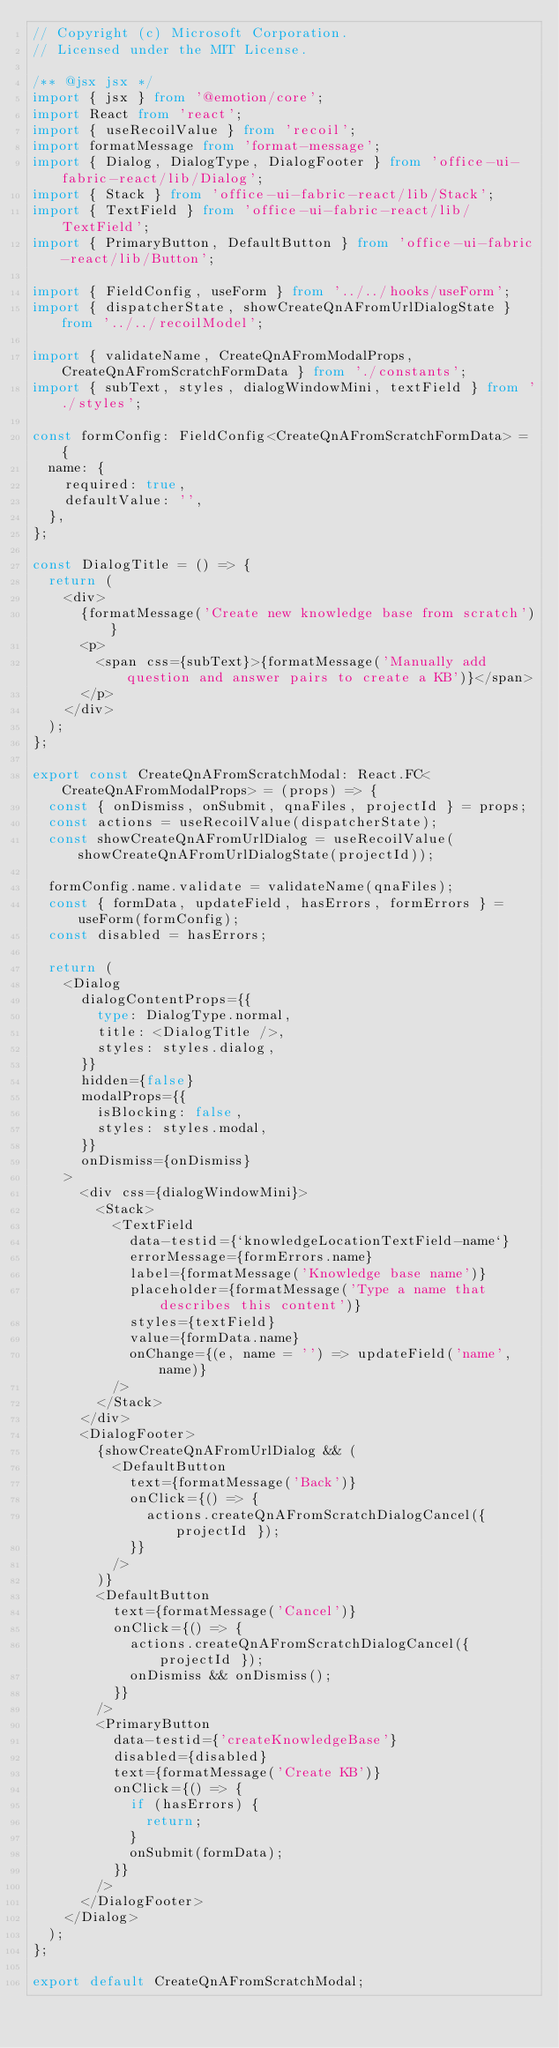<code> <loc_0><loc_0><loc_500><loc_500><_TypeScript_>// Copyright (c) Microsoft Corporation.
// Licensed under the MIT License.

/** @jsx jsx */
import { jsx } from '@emotion/core';
import React from 'react';
import { useRecoilValue } from 'recoil';
import formatMessage from 'format-message';
import { Dialog, DialogType, DialogFooter } from 'office-ui-fabric-react/lib/Dialog';
import { Stack } from 'office-ui-fabric-react/lib/Stack';
import { TextField } from 'office-ui-fabric-react/lib/TextField';
import { PrimaryButton, DefaultButton } from 'office-ui-fabric-react/lib/Button';

import { FieldConfig, useForm } from '../../hooks/useForm';
import { dispatcherState, showCreateQnAFromUrlDialogState } from '../../recoilModel';

import { validateName, CreateQnAFromModalProps, CreateQnAFromScratchFormData } from './constants';
import { subText, styles, dialogWindowMini, textField } from './styles';

const formConfig: FieldConfig<CreateQnAFromScratchFormData> = {
  name: {
    required: true,
    defaultValue: '',
  },
};

const DialogTitle = () => {
  return (
    <div>
      {formatMessage('Create new knowledge base from scratch')}
      <p>
        <span css={subText}>{formatMessage('Manually add question and answer pairs to create a KB')}</span>
      </p>
    </div>
  );
};

export const CreateQnAFromScratchModal: React.FC<CreateQnAFromModalProps> = (props) => {
  const { onDismiss, onSubmit, qnaFiles, projectId } = props;
  const actions = useRecoilValue(dispatcherState);
  const showCreateQnAFromUrlDialog = useRecoilValue(showCreateQnAFromUrlDialogState(projectId));

  formConfig.name.validate = validateName(qnaFiles);
  const { formData, updateField, hasErrors, formErrors } = useForm(formConfig);
  const disabled = hasErrors;

  return (
    <Dialog
      dialogContentProps={{
        type: DialogType.normal,
        title: <DialogTitle />,
        styles: styles.dialog,
      }}
      hidden={false}
      modalProps={{
        isBlocking: false,
        styles: styles.modal,
      }}
      onDismiss={onDismiss}
    >
      <div css={dialogWindowMini}>
        <Stack>
          <TextField
            data-testid={`knowledgeLocationTextField-name`}
            errorMessage={formErrors.name}
            label={formatMessage('Knowledge base name')}
            placeholder={formatMessage('Type a name that describes this content')}
            styles={textField}
            value={formData.name}
            onChange={(e, name = '') => updateField('name', name)}
          />
        </Stack>
      </div>
      <DialogFooter>
        {showCreateQnAFromUrlDialog && (
          <DefaultButton
            text={formatMessage('Back')}
            onClick={() => {
              actions.createQnAFromScratchDialogCancel({ projectId });
            }}
          />
        )}
        <DefaultButton
          text={formatMessage('Cancel')}
          onClick={() => {
            actions.createQnAFromScratchDialogCancel({ projectId });
            onDismiss && onDismiss();
          }}
        />
        <PrimaryButton
          data-testid={'createKnowledgeBase'}
          disabled={disabled}
          text={formatMessage('Create KB')}
          onClick={() => {
            if (hasErrors) {
              return;
            }
            onSubmit(formData);
          }}
        />
      </DialogFooter>
    </Dialog>
  );
};

export default CreateQnAFromScratchModal;
</code> 